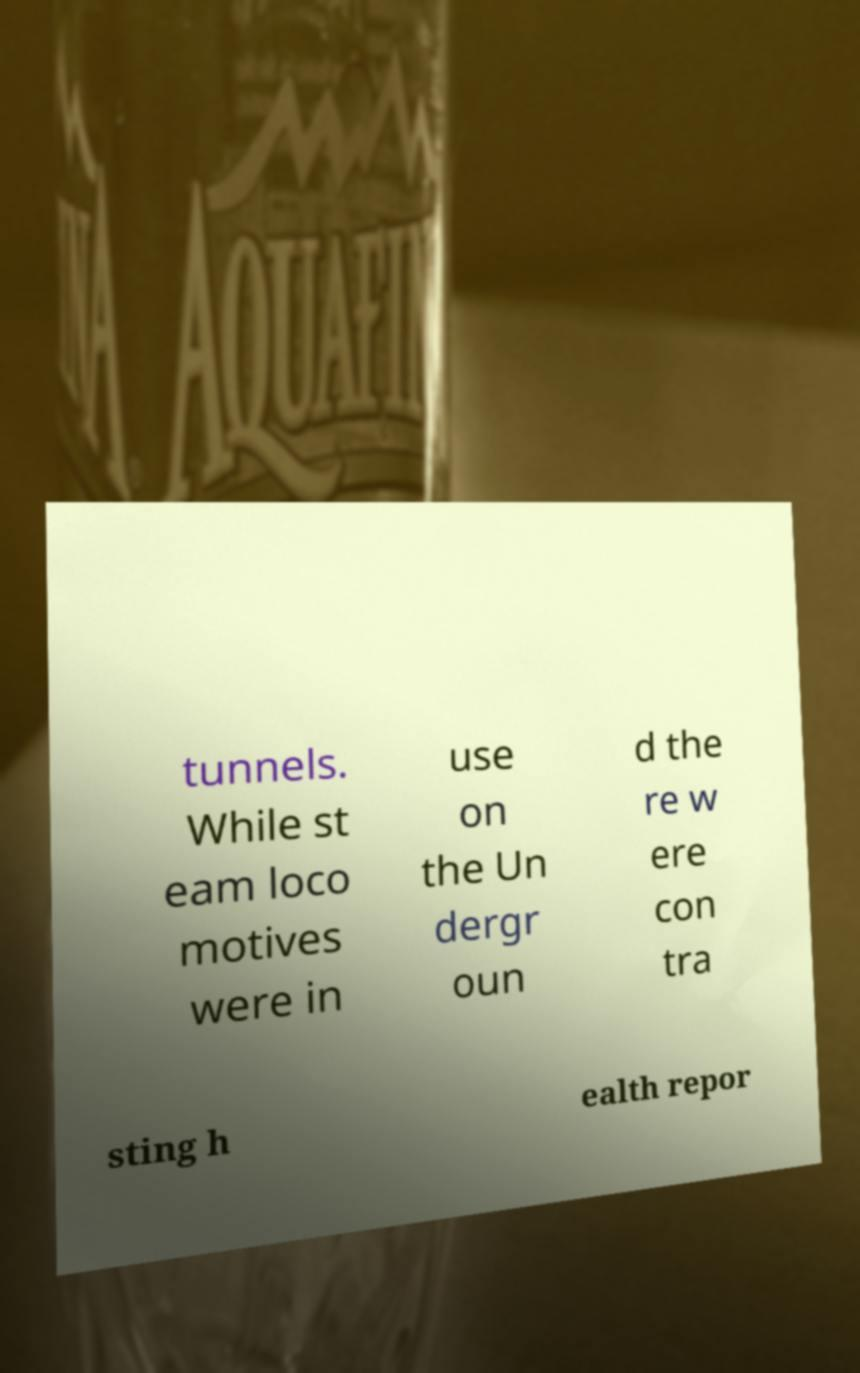For documentation purposes, I need the text within this image transcribed. Could you provide that? tunnels. While st eam loco motives were in use on the Un dergr oun d the re w ere con tra sting h ealth repor 